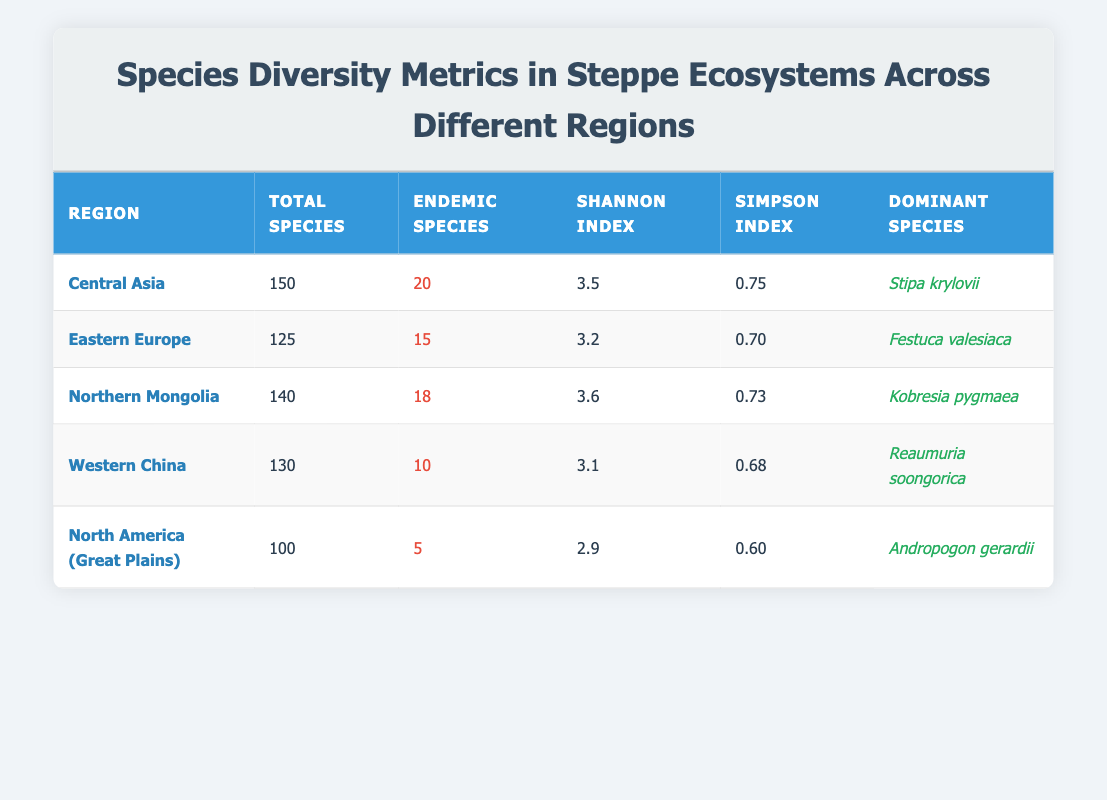What is the total number of species in Northern Mongolia? To find the total number of species in Northern Mongolia, we refer to the corresponding row in the table, which shows that the total species listed for this region is 140.
Answer: 140 Which region has the highest Shannon Index? The Shannon Index values can be compared across the regions. In the table, Northern Mongolia has the highest value of 3.6, which is greater than the values for other regions.
Answer: Northern Mongolia What is the difference between the total species in Central Asia and North America (Great Plains)? To find the difference, we subtract the total species in North America (Great Plains, which is 100) from that in Central Asia (150). The calculation is 150 - 100 = 50.
Answer: 50 How many endemic species are there across all regions combined? We add the endemic species from each region: 20 (Central Asia) + 15 (Eastern Europe) + 18 (Northern Mongolia) + 10 (Western China) + 5 (North America) = 78 endemic species.
Answer: 78 Is the dominant species in Eastern Europe listed as Festuca valesiaca? By checking the row for Eastern Europe, it states that the dominant species is indeed Festuca valesiaca. Therefore, the answer is true.
Answer: Yes Does the region with the most total species also have the most endemic species? The region with the most total species is Central Asia (150 total). However, it has 20 endemic species. In comparison, North America has only 100 total species and 5 endemic species. Thus, Central Asia has more total species but not necessarily more endemic species compared to others, making this statement false.
Answer: No Which region has the lowest Simpson Index and what is its value? The Simpson Index values must be examined for all regions. The lowest value is found in North America (Great Plains), which is 0.60 according to the data in the table.
Answer: 0.60 What is the average Shannon Index of the regions listed? We first add all the Shannon Index values: 3.5 (Central Asia) + 3.2 (Eastern Europe) + 3.6 (Northern Mongolia) + 3.1 (Western China) + 2.9 (North America) = 16.3. Then, we divide by the number of regions (5) to get the average: 16.3 / 5 = 3.26.
Answer: 3.26 In which region is the dominant species Kobresia pygmaea found? Referring to the table, we see that Kobresia pygmaea is identified as the dominant species in Northern Mongolia.
Answer: Northern Mongolia 